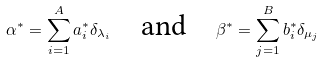<formula> <loc_0><loc_0><loc_500><loc_500>\alpha ^ { * } = \sum _ { i = 1 } ^ { A } a _ { i } ^ { * } \delta _ { \lambda _ { i } } \quad \text {and} \quad \beta ^ { * } = \sum _ { j = 1 } ^ { B } b _ { i } ^ { * } \delta _ { \mu _ { j } }</formula> 